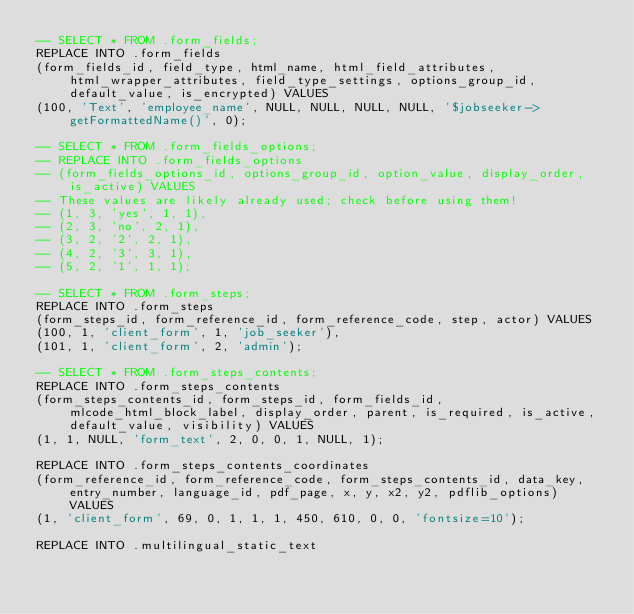Convert code to text. <code><loc_0><loc_0><loc_500><loc_500><_SQL_>-- SELECT * FROM .form_fields;
REPLACE INTO .form_fields
(form_fields_id, field_type, html_name, html_field_attributes, html_wrapper_attributes, field_type_settings, options_group_id, default_value, is_encrypted) VALUES
(100, 'Text', 'employee_name', NULL, NULL, NULL, NULL, '$jobseeker->getFormattedName()', 0);

-- SELECT * FROM .form_fields_options;
-- REPLACE INTO .form_fields_options
-- (form_fields_options_id, options_group_id, option_value, display_order, is_active) VALUES
-- These values are likely already used; check before using them!
-- (1, 3, 'yes', 1, 1),
-- (2, 3, 'no', 2, 1),
-- (3, 2, '2', 2, 1),
-- (4, 2, '3', 3, 1),
-- (5, 2, '1', 1, 1);

-- SELECT * FROM .form_steps;
REPLACE INTO .form_steps
(form_steps_id, form_reference_id, form_reference_code, step, actor) VALUES
(100, 1, 'client_form', 1, 'job_seeker'),
(101, 1, 'client_form', 2, 'admin');

-- SELECT * FROM .form_steps_contents;
REPLACE INTO .form_steps_contents
(form_steps_contents_id, form_steps_id, form_fields_id, mlcode_html_block_label, display_order, parent, is_required, is_active, default_value, visibility) VALUES
(1, 1, NULL, 'form_text', 2, 0, 0, 1, NULL, 1);

REPLACE INTO .form_steps_contents_coordinates
(form_reference_id, form_reference_code, form_steps_contents_id, data_key, entry_number, language_id, pdf_page, x, y, x2, y2, pdflib_options) VALUES
(1, 'client_form', 69, 0, 1, 1, 1, 450, 610, 0, 0, 'fontsize=10');

REPLACE INTO .multilingual_static_text</code> 